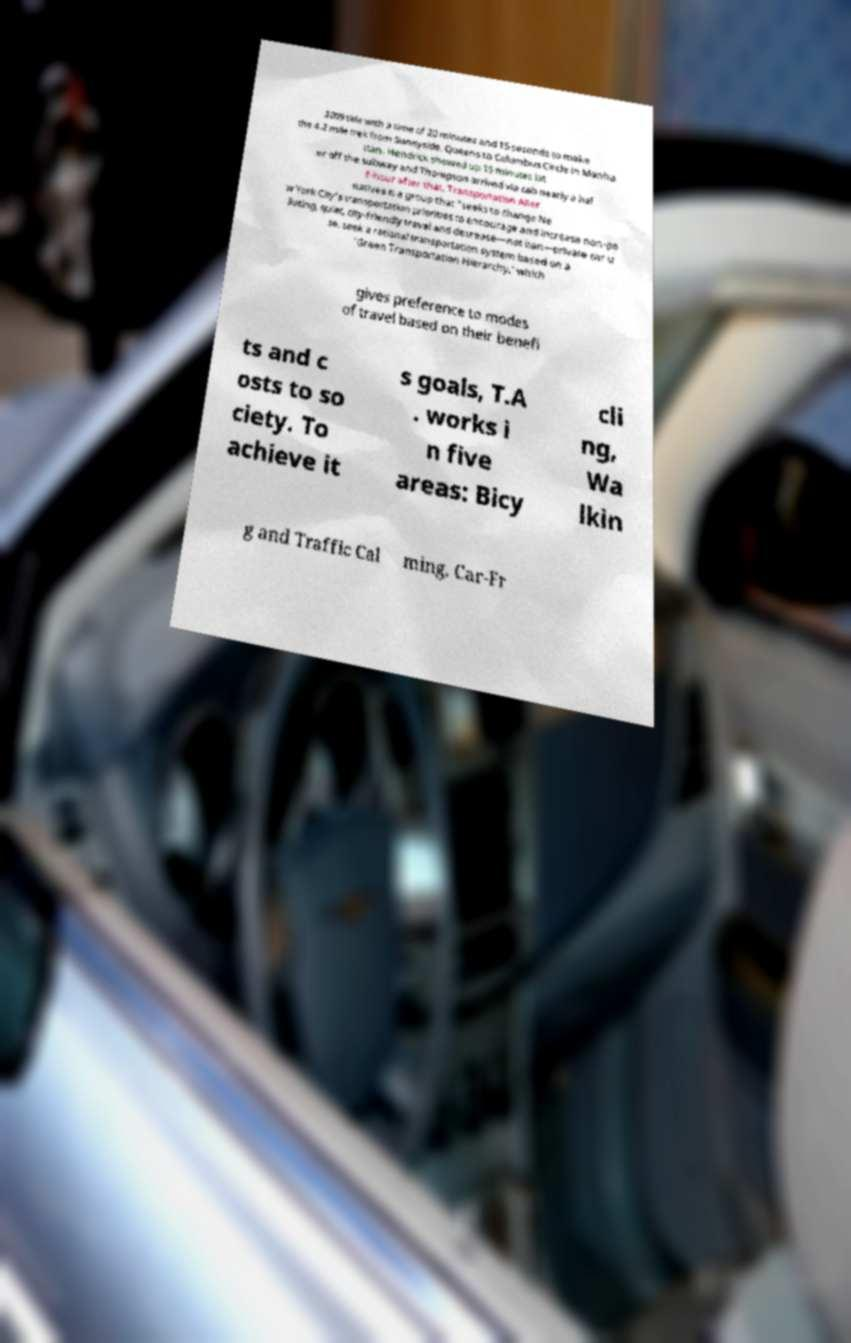Please read and relay the text visible in this image. What does it say? 2009 title with a time of 20 minutes and 15 seconds to make the 4.2 mile trek from Sunnyside, Queens to Columbus Circle in Manha ttan. Hendrick showed up 15 minutes lat er off the subway and Thompson arrived via cab nearly a hal f-hour after that. Transportation Alter natives is a group that "seeks to change Ne w York City's transportation priorities to encourage and increase non-po lluting, quiet, city-friendly travel and decrease—not ban—private car u se. seek a rational transportation system based on a 'Green Transportation Hierarchy,' which gives preference to modes of travel based on their benefi ts and c osts to so ciety. To achieve it s goals, T.A . works i n five areas: Bicy cli ng, Wa lkin g and Traffic Cal ming, Car-Fr 